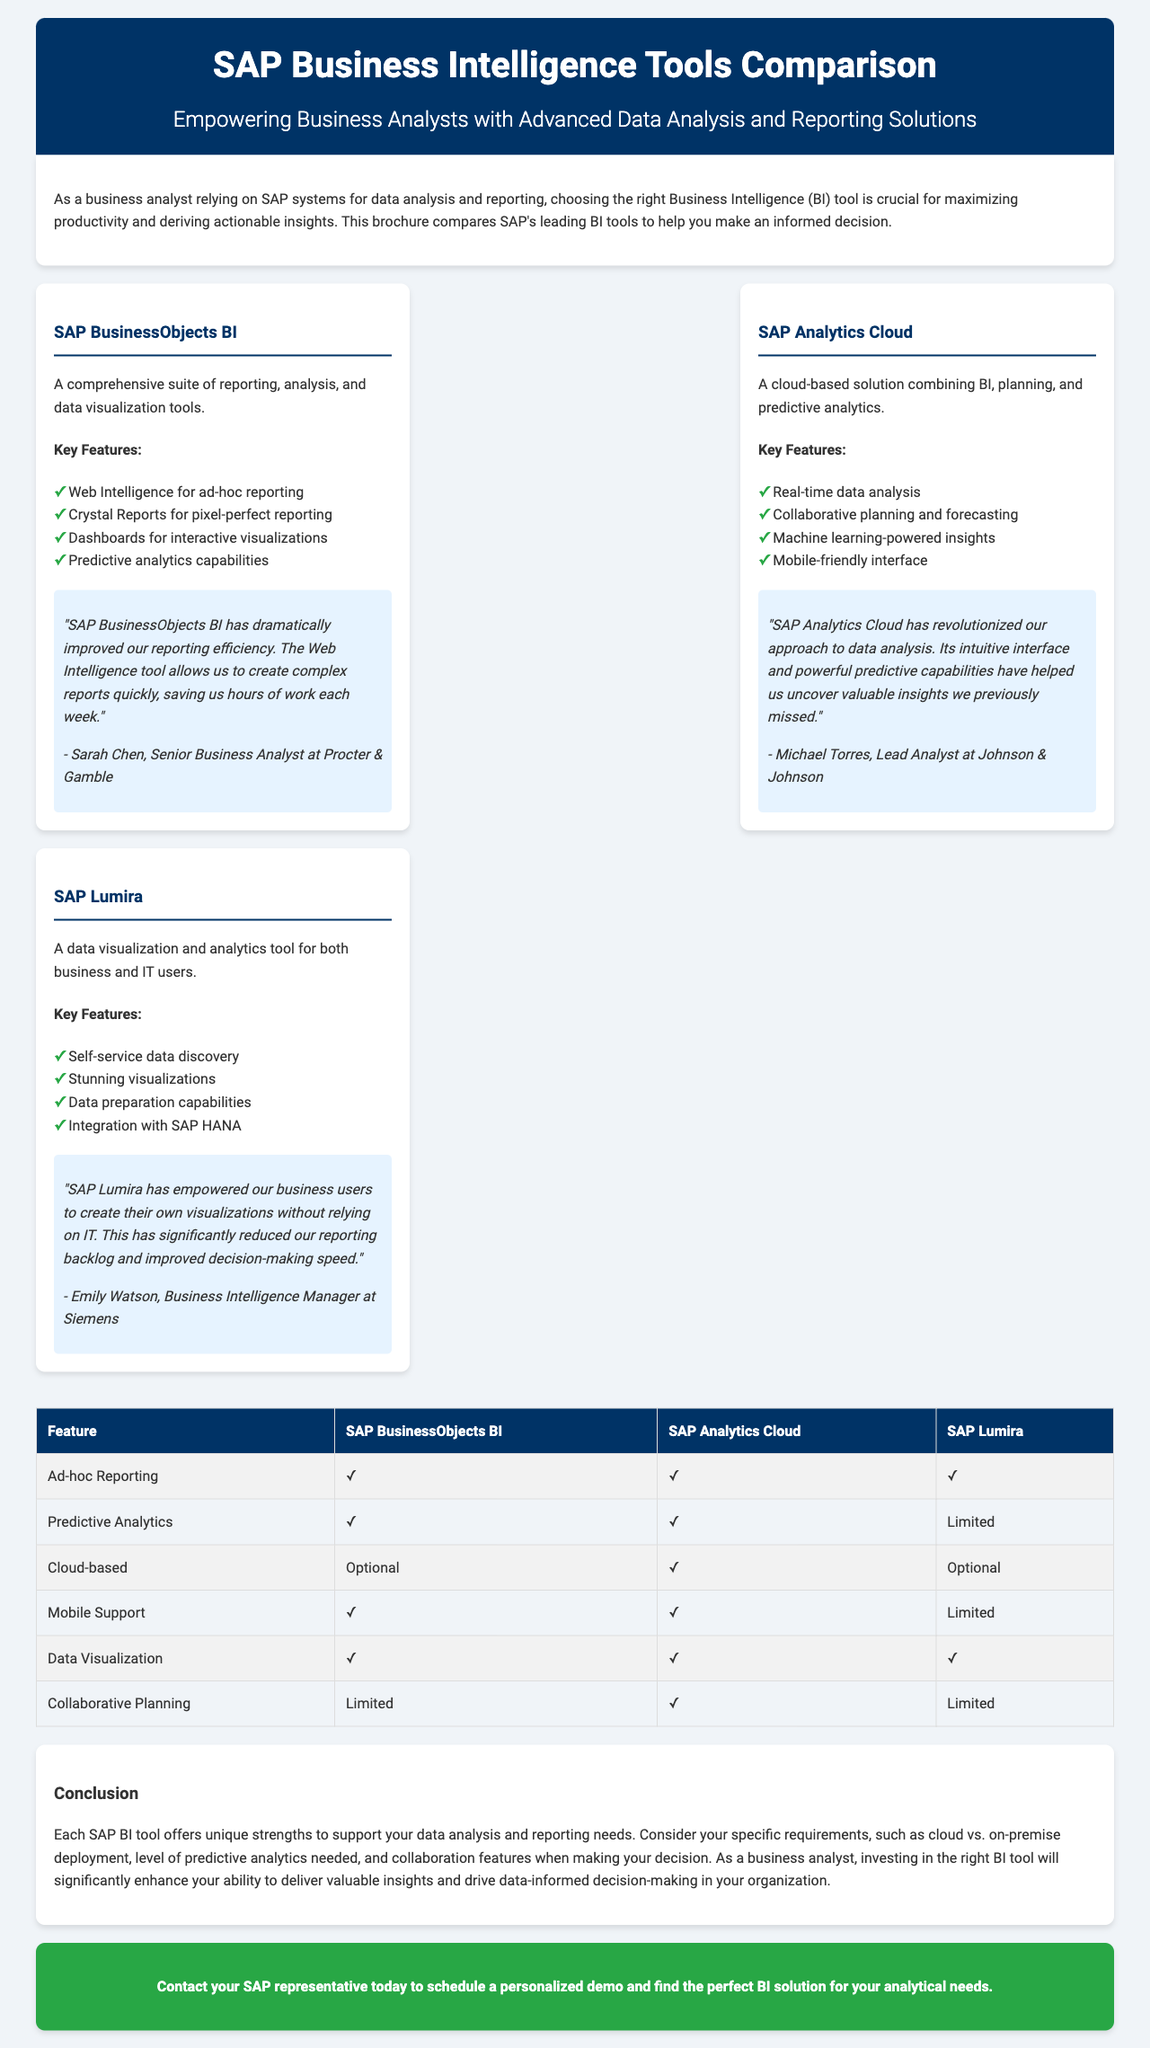What is the subtitle of the brochure? The subtitle is a key detail that provides more context about the brochure's purpose.
Answer: Empowering Business Analysts with Advanced Data Analysis and Reporting Solutions Which tool is described as a cloud-based solution? The description mentions one tool combines BI, planning, and predictive analytics, indicating its cloud-based nature.
Answer: SAP Analytics Cloud How many key features does SAP Lumira have? The number of key features is relevant to understanding the capabilities of SAP Lumira compared to other tools.
Answer: Four Who is the user testimonial for SAP BusinessObjects BI from? The source of user testimonials often conveys the credibility of the feedback regarding the tool's performance.
Answer: Sarah Chen What feature is limited in SAP Lumira compared to others? Identifying limited features helps users understand the tool's constraints in functionality.
Answer: Predictive Analytics Which tool has optional cloud-based deployment? Understanding deployment options is crucial for businesses when choosing a BI tool.
Answer: SAP BusinessObjects BI What is the main benefit of SAP Lumira according to its user testimonial? This provides insights into real user experiences and how the tool impacts their work.
Answer: Empowered business users to create their own visualizations How many tools mentioned have ad-hoc reporting capability? Knowing the capabilities related to reporting helps users evaluate their options based on needs.
Answer: Three 